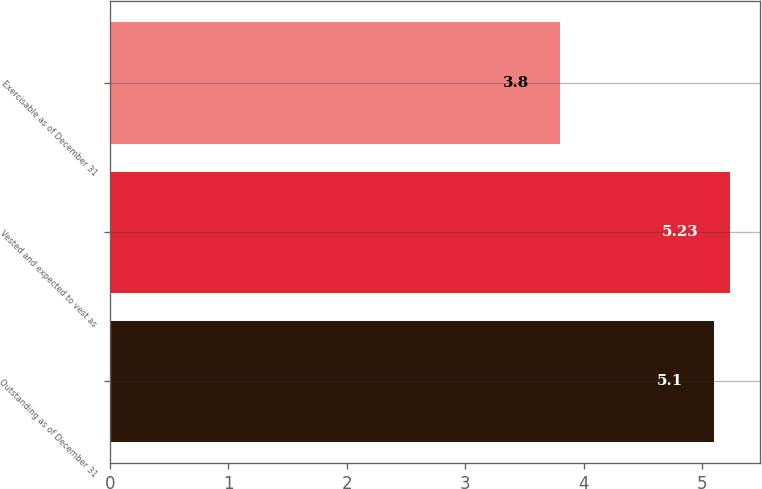<chart> <loc_0><loc_0><loc_500><loc_500><bar_chart><fcel>Outstanding as of December 31<fcel>Vested and expected to vest as<fcel>Exercisable as of December 31<nl><fcel>5.1<fcel>5.23<fcel>3.8<nl></chart> 